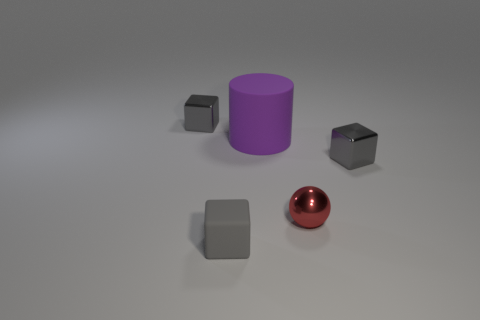There is a purple cylinder that is behind the small metallic object that is in front of the metallic cube in front of the matte cylinder; what size is it?
Give a very brief answer. Large. What material is the red thing?
Provide a short and direct response. Metal. Do the tiny ball and the thing on the right side of the red thing have the same material?
Keep it short and to the point. Yes. Are there any other things that are the same color as the big cylinder?
Provide a short and direct response. No. There is a rubber thing behind the small gray metallic cube in front of the purple thing; is there a gray rubber block on the left side of it?
Offer a very short reply. Yes. What color is the small ball?
Keep it short and to the point. Red. Are there any metallic things to the right of the metal ball?
Provide a short and direct response. Yes. There is a tiny gray rubber object; is it the same shape as the gray thing to the right of the big matte thing?
Make the answer very short. Yes. How many other objects are the same material as the small red thing?
Your response must be concise. 2. What is the color of the metal cube behind the shiny cube that is to the right of the small thing that is in front of the small metallic ball?
Keep it short and to the point. Gray. 